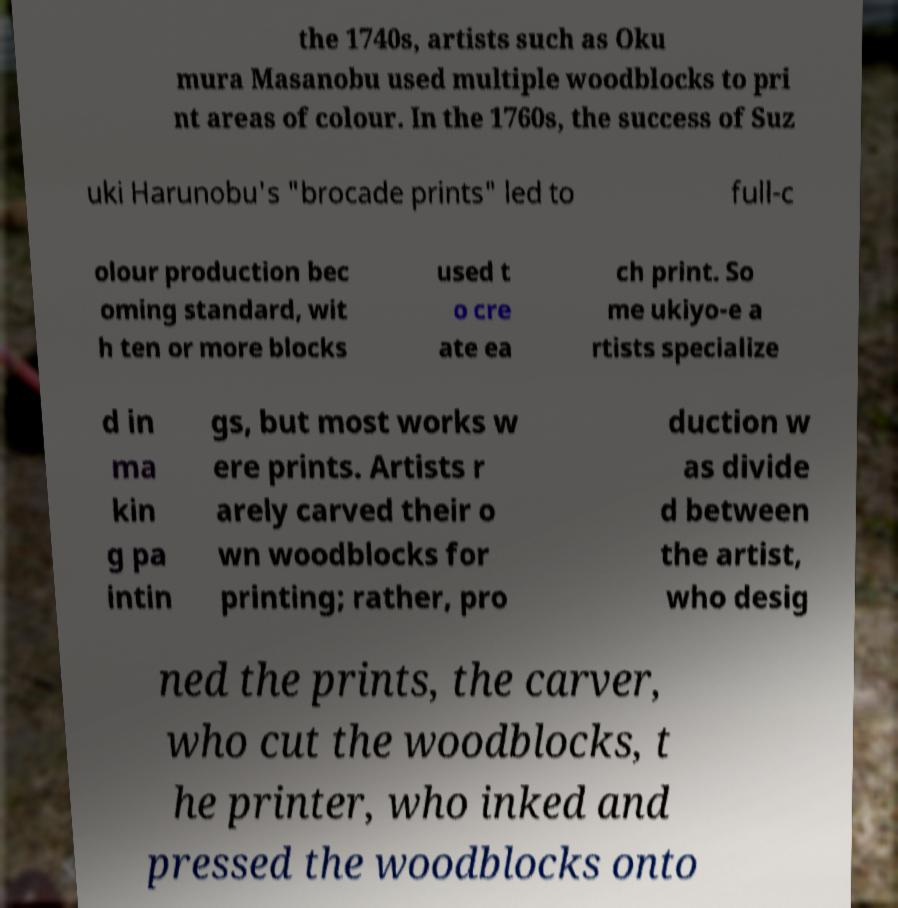What messages or text are displayed in this image? I need them in a readable, typed format. the 1740s, artists such as Oku mura Masanobu used multiple woodblocks to pri nt areas of colour. In the 1760s, the success of Suz uki Harunobu's "brocade prints" led to full-c olour production bec oming standard, wit h ten or more blocks used t o cre ate ea ch print. So me ukiyo-e a rtists specialize d in ma kin g pa intin gs, but most works w ere prints. Artists r arely carved their o wn woodblocks for printing; rather, pro duction w as divide d between the artist, who desig ned the prints, the carver, who cut the woodblocks, t he printer, who inked and pressed the woodblocks onto 